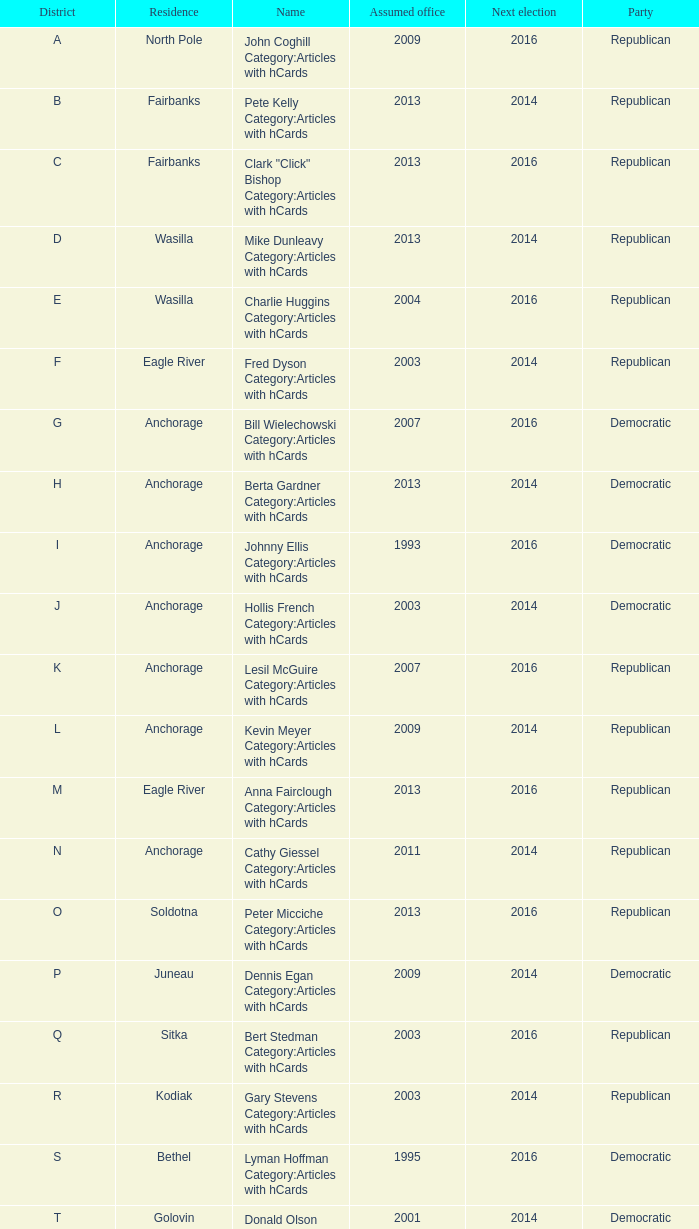What is the party of the Senator in District A, who assumed office before 2013 and will be up for re-election after 2014? Republican. 